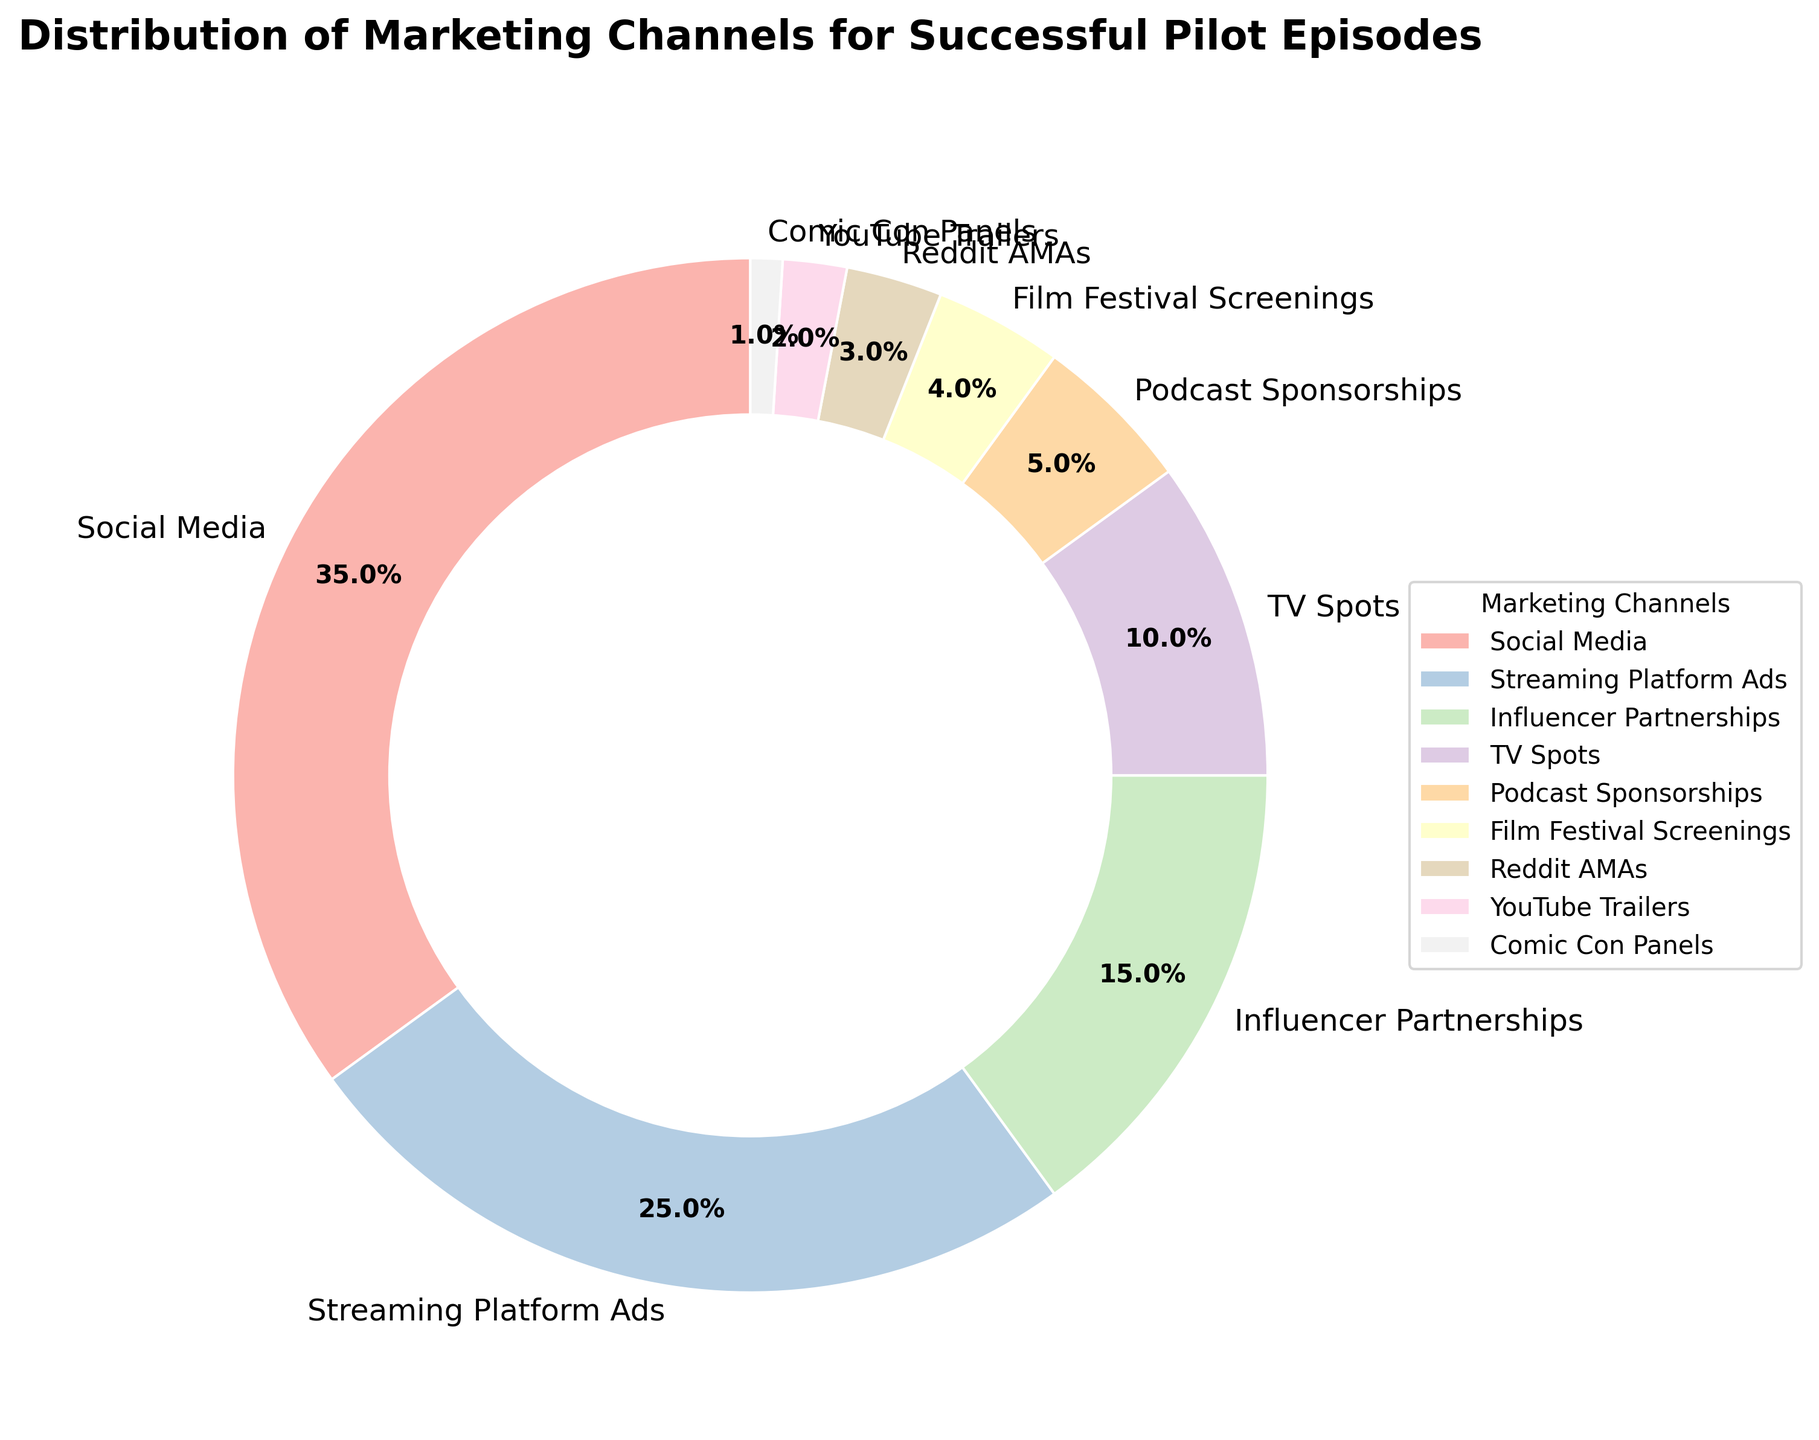What percentage of the marketing is done through social media? By referring to the pie chart, we see that the segment associated with Social Media is labeled with its corresponding percentage.
Answer: 35% What is the combined percentage of marketing done through Influencer Partnerships, Podcast Sponsorships, and Reddit AMAs? We need to add the individual percentages for Influencer Partnerships, Podcast Sponsorships, and Reddit AMAs (15% + 5% + 3%). This gives us a total of 23%.
Answer: 23% Which marketing channel uses a higher percentage, TV Spots, or Streaming Platform Ads? By comparing the segments of TV Spots and Streaming Platform Ads, we see that TV Spots have a smaller segment labeled 10%, whereas Streaming Platform Ads have a larger segment labeled 25%.
Answer: Streaming Platform Ads What is the difference in percentage between the highest and lowest marketing channels? We need to subtract the percentage of the lowest segment (Comic Con Panels, 1%) from the highest segment (Social Media, 35%). The difference is 35% - 1% = 34%.
Answer: 34% If the percentage for Influencer Partnerships doubled, what would the new total percentage of all channels be? If the percentage for Influencer Partnerships doubled from 15% to 30%, the new total percentage would be all the original percentages plus the increase (15%). The original total is 100%, so the new total would be 100% + 15% = 115%.
Answer: 115% What's the difference in percentage between YouTube Trailers and Comic Con Panels? Subtract the percentage for Comic Con Panels (1%) from the percentage for YouTube Trailers (2%) to get the difference. 2% - 1% = 1%.
Answer: 1% Which marketing channels contribute less than 5% to the overall distribution? From the pie chart, segments labeled with less than 5% are Film Festival Screenings (4%), Reddit AMAs (3%), YouTube Trailers (2%), and Comic Con Panels (1%).
Answer: Film Festival Screenings, Reddit AMAs, YouTube Trailers, Comic Con Panels How many marketing channels have a percentage equal to or greater than 10%? Referring to the pie chart, segments with percentages 10% and above are Social Media (35%), Streaming Platform Ads (25%), Influencer Partnerships (15%), and TV Spots (10%). This makes a total of 4 channels.
Answer: 4 What portion of the distribution does Social Media and Streaming Platform Ads collectively represent? By adding the percentages of Social Media (35%) and Streaming Platform Ads (25%), we get a total of 35% + 25% = 60%.
Answer: 60% How much more percentage does Influencer Partnerships contribute compared to Podcast Sponsorships? Subtract the percentage of Podcast Sponsorships (5%) from Influencer Partnerships (15%) to find the difference. 15% - 5% = 10%.
Answer: 10% 